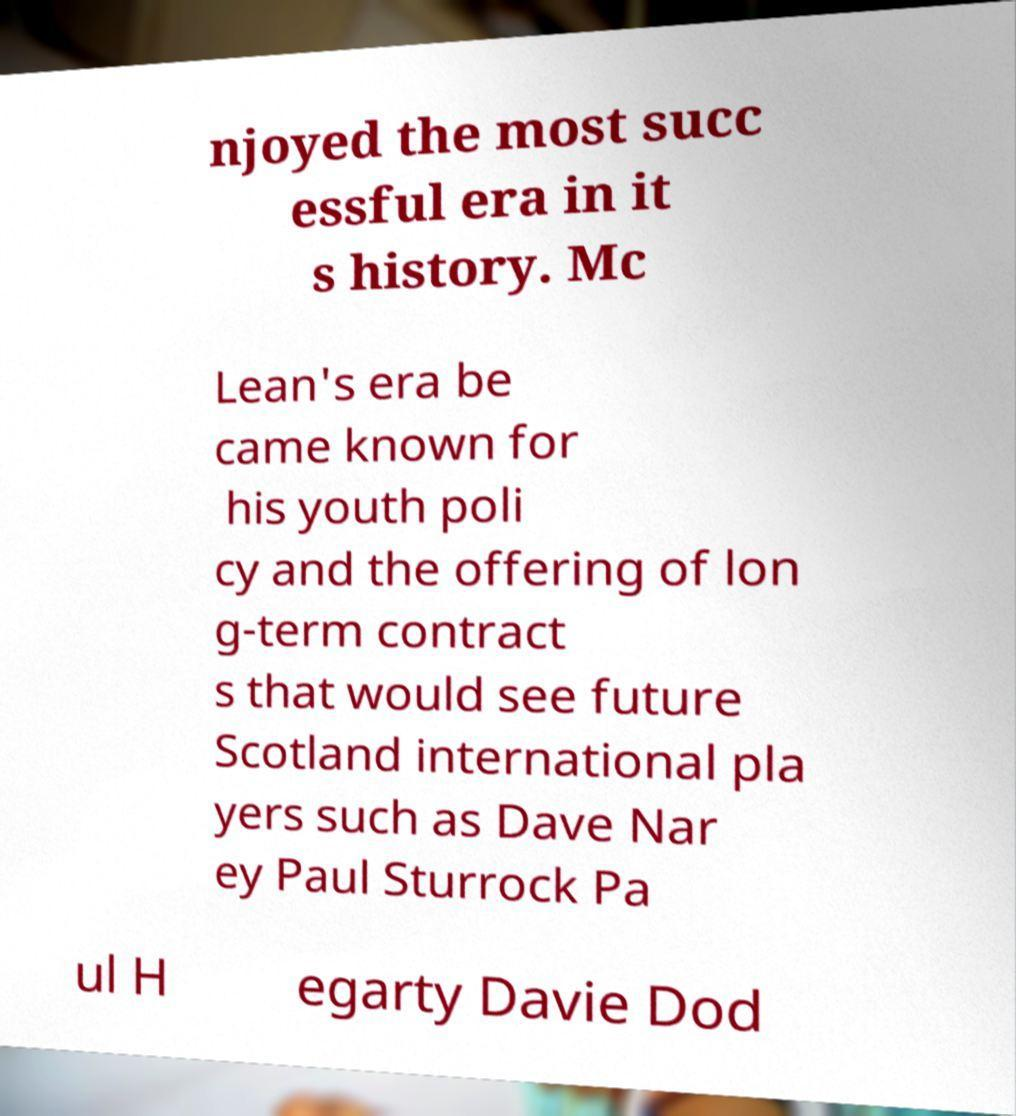Could you assist in decoding the text presented in this image and type it out clearly? njoyed the most succ essful era in it s history. Mc Lean's era be came known for his youth poli cy and the offering of lon g-term contract s that would see future Scotland international pla yers such as Dave Nar ey Paul Sturrock Pa ul H egarty Davie Dod 